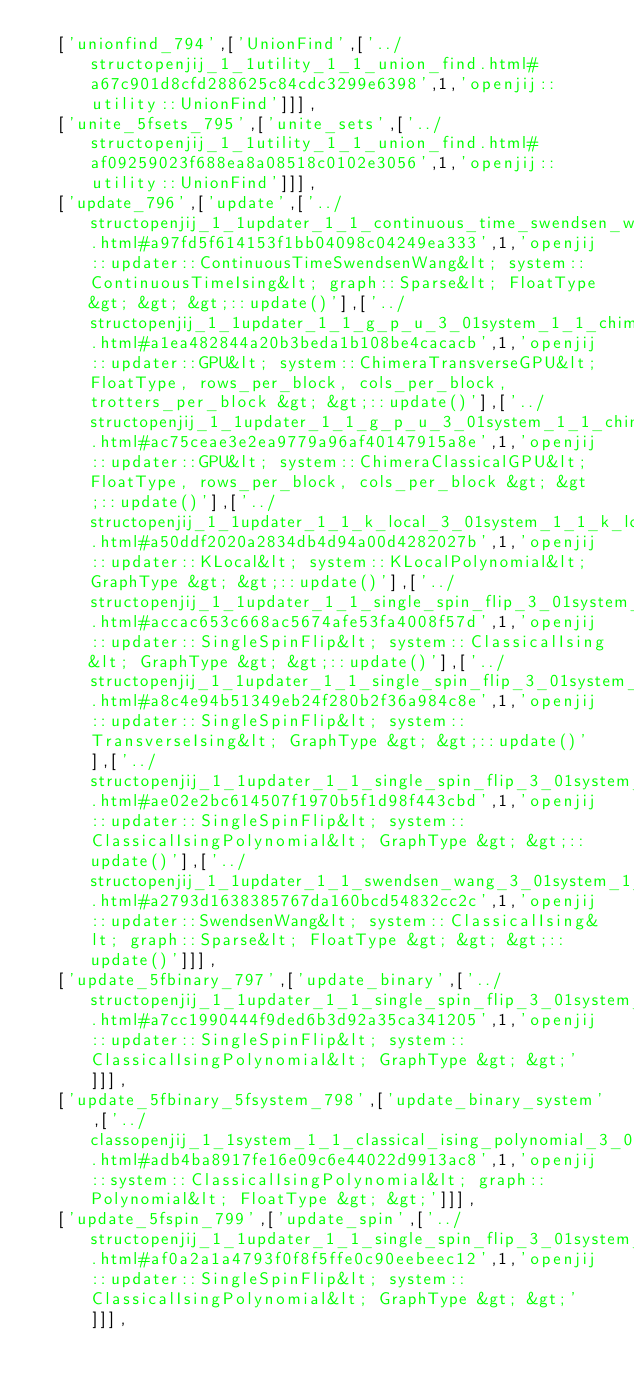Convert code to text. <code><loc_0><loc_0><loc_500><loc_500><_JavaScript_>  ['unionfind_794',['UnionFind',['../structopenjij_1_1utility_1_1_union_find.html#a67c901d8cfd288625c84cdc3299e6398',1,'openjij::utility::UnionFind']]],
  ['unite_5fsets_795',['unite_sets',['../structopenjij_1_1utility_1_1_union_find.html#af09259023f688ea8a08518c0102e3056',1,'openjij::utility::UnionFind']]],
  ['update_796',['update',['../structopenjij_1_1updater_1_1_continuous_time_swendsen_wang_3_01system_1_1_continuous_time_ising_51a9df2fdc9c374a39d66520dc741874.html#a97fd5f614153f1bb04098c04249ea333',1,'openjij::updater::ContinuousTimeSwendsenWang&lt; system::ContinuousTimeIsing&lt; graph::Sparse&lt; FloatType &gt; &gt; &gt;::update()'],['../structopenjij_1_1updater_1_1_g_p_u_3_01system_1_1_chimera_transverse_g_p_u_3_01_float_type_00_01b19d630807b301686e9b8e0e0cbea249.html#a1ea482844a20b3beda1b108be4cacacb',1,'openjij::updater::GPU&lt; system::ChimeraTransverseGPU&lt; FloatType, rows_per_block, cols_per_block, trotters_per_block &gt; &gt;::update()'],['../structopenjij_1_1updater_1_1_g_p_u_3_01system_1_1_chimera_classical_g_p_u_3_01_float_type_00_01r4fcead86cd6a048bb091f4694e05e19a.html#ac75ceae3e2ea9779a96af40147915a8e',1,'openjij::updater::GPU&lt; system::ChimeraClassicalGPU&lt; FloatType, rows_per_block, cols_per_block &gt; &gt;::update()'],['../structopenjij_1_1updater_1_1_k_local_3_01system_1_1_k_local_polynomial_3_01_graph_type_01_4_01_4.html#a50ddf2020a2834db4d94a00d4282027b',1,'openjij::updater::KLocal&lt; system::KLocalPolynomial&lt; GraphType &gt; &gt;::update()'],['../structopenjij_1_1updater_1_1_single_spin_flip_3_01system_1_1_classical_ising_3_01_graph_type_01_4_01_4.html#accac653c668ac5674afe53fa4008f57d',1,'openjij::updater::SingleSpinFlip&lt; system::ClassicalIsing&lt; GraphType &gt; &gt;::update()'],['../structopenjij_1_1updater_1_1_single_spin_flip_3_01system_1_1_transverse_ising_3_01_graph_type_01_4_01_4.html#a8c4e94b51349eb24f280b2f36a984c8e',1,'openjij::updater::SingleSpinFlip&lt; system::TransverseIsing&lt; GraphType &gt; &gt;::update()'],['../structopenjij_1_1updater_1_1_single_spin_flip_3_01system_1_1_classical_ising_polynomial_3_01_graph_type_01_4_01_4.html#ae02e2bc614507f1970b5f1d98f443cbd',1,'openjij::updater::SingleSpinFlip&lt; system::ClassicalIsingPolynomial&lt; GraphType &gt; &gt;::update()'],['../structopenjij_1_1updater_1_1_swendsen_wang_3_01system_1_1_classical_ising_3_01graph_1_1_sparse_3_01_float_type_01_4_01_4_01_4.html#a2793d1638385767da160bcd54832cc2c',1,'openjij::updater::SwendsenWang&lt; system::ClassicalIsing&lt; graph::Sparse&lt; FloatType &gt; &gt; &gt;::update()']]],
  ['update_5fbinary_797',['update_binary',['../structopenjij_1_1updater_1_1_single_spin_flip_3_01system_1_1_classical_ising_polynomial_3_01_graph_type_01_4_01_4.html#a7cc1990444f9ded6b3d92a35ca341205',1,'openjij::updater::SingleSpinFlip&lt; system::ClassicalIsingPolynomial&lt; GraphType &gt; &gt;']]],
  ['update_5fbinary_5fsystem_798',['update_binary_system',['../classopenjij_1_1system_1_1_classical_ising_polynomial_3_01graph_1_1_polynomial_3_01_float_type_01_4_01_4.html#adb4ba8917fe16e09c6e44022d9913ac8',1,'openjij::system::ClassicalIsingPolynomial&lt; graph::Polynomial&lt; FloatType &gt; &gt;']]],
  ['update_5fspin_799',['update_spin',['../structopenjij_1_1updater_1_1_single_spin_flip_3_01system_1_1_classical_ising_polynomial_3_01_graph_type_01_4_01_4.html#af0a2a1a4793f0f8f5ffe0c90eebeec12',1,'openjij::updater::SingleSpinFlip&lt; system::ClassicalIsingPolynomial&lt; GraphType &gt; &gt;']]],</code> 